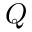Convert formula to latex. <formula><loc_0><loc_0><loc_500><loc_500>Q</formula> 